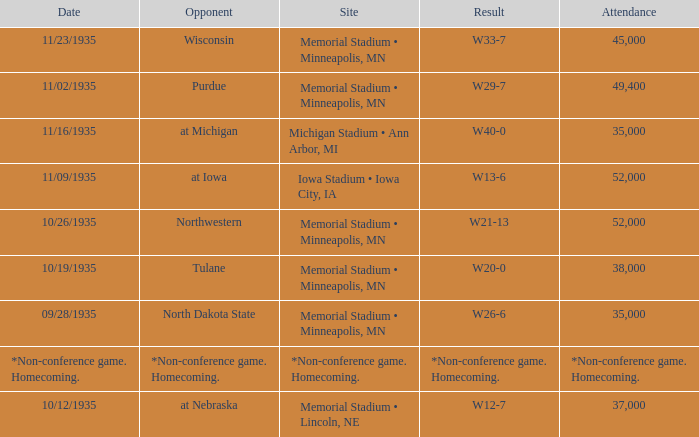Who was the opponent against which the result was w20-0? Tulane. 